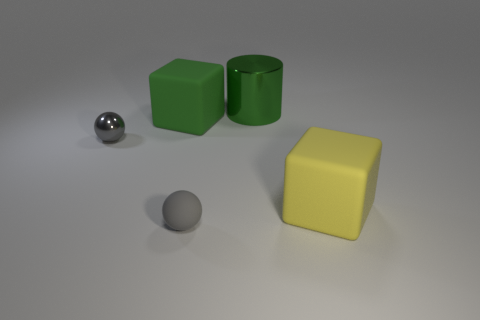Do the gray matte thing and the yellow object have the same shape?
Your answer should be compact. No. What is the color of the object that is both in front of the gray metallic sphere and on the right side of the rubber ball?
Give a very brief answer. Yellow. What size is the shiny thing that is the same color as the matte ball?
Make the answer very short. Small. What number of large objects are either gray blocks or green cubes?
Offer a terse response. 1. Is there anything else that has the same color as the cylinder?
Ensure brevity in your answer.  Yes. What material is the gray thing in front of the sphere behind the small gray thing in front of the small gray metallic thing made of?
Provide a succinct answer. Rubber. What number of rubber things are red cylinders or large blocks?
Make the answer very short. 2. How many green objects are shiny cylinders or spheres?
Your response must be concise. 1. There is a big thing that is in front of the big green matte thing; does it have the same color as the cylinder?
Offer a terse response. No. Is the yellow cube made of the same material as the green cylinder?
Keep it short and to the point. No. 